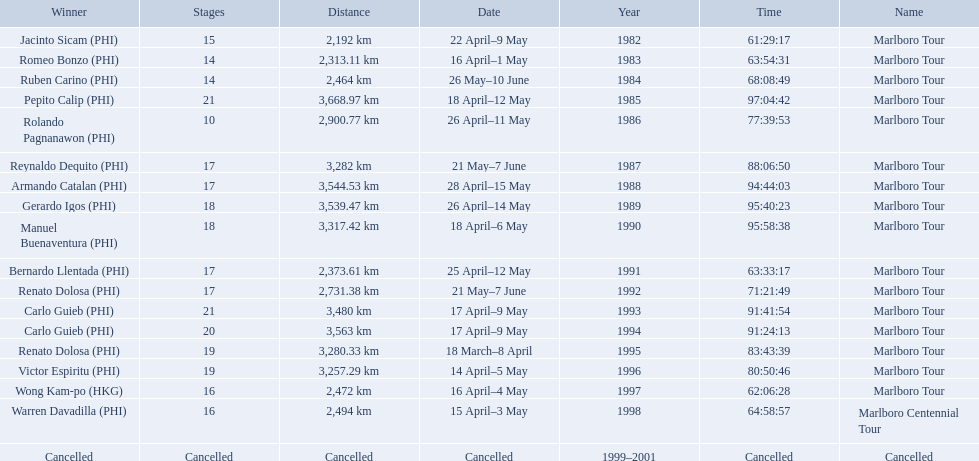How far did the marlboro tour travel each year? 2,192 km, 2,313.11 km, 2,464 km, 3,668.97 km, 2,900.77 km, 3,282 km, 3,544.53 km, 3,539.47 km, 3,317.42 km, 2,373.61 km, 2,731.38 km, 3,480 km, 3,563 km, 3,280.33 km, 3,257.29 km, 2,472 km, 2,494 km, Cancelled. In what year did they travel the furthest? 1985. How far did they travel that year? 3,668.97 km. 